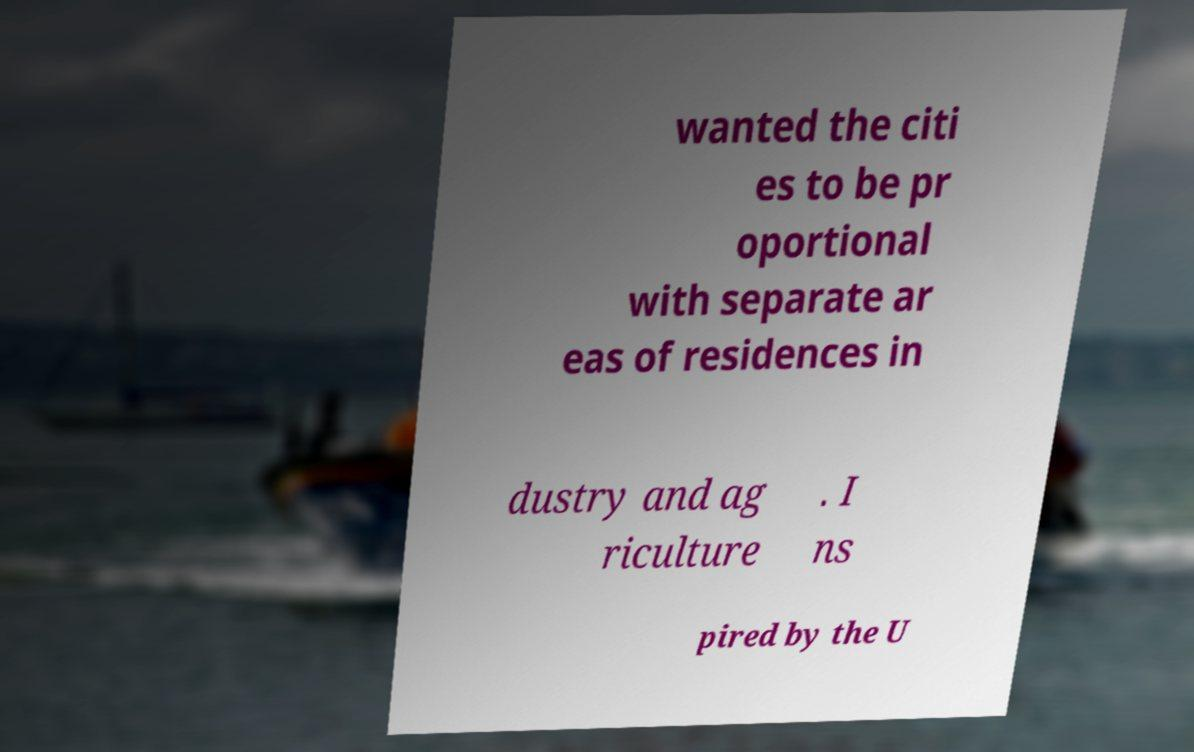Can you read and provide the text displayed in the image?This photo seems to have some interesting text. Can you extract and type it out for me? wanted the citi es to be pr oportional with separate ar eas of residences in dustry and ag riculture . I ns pired by the U 